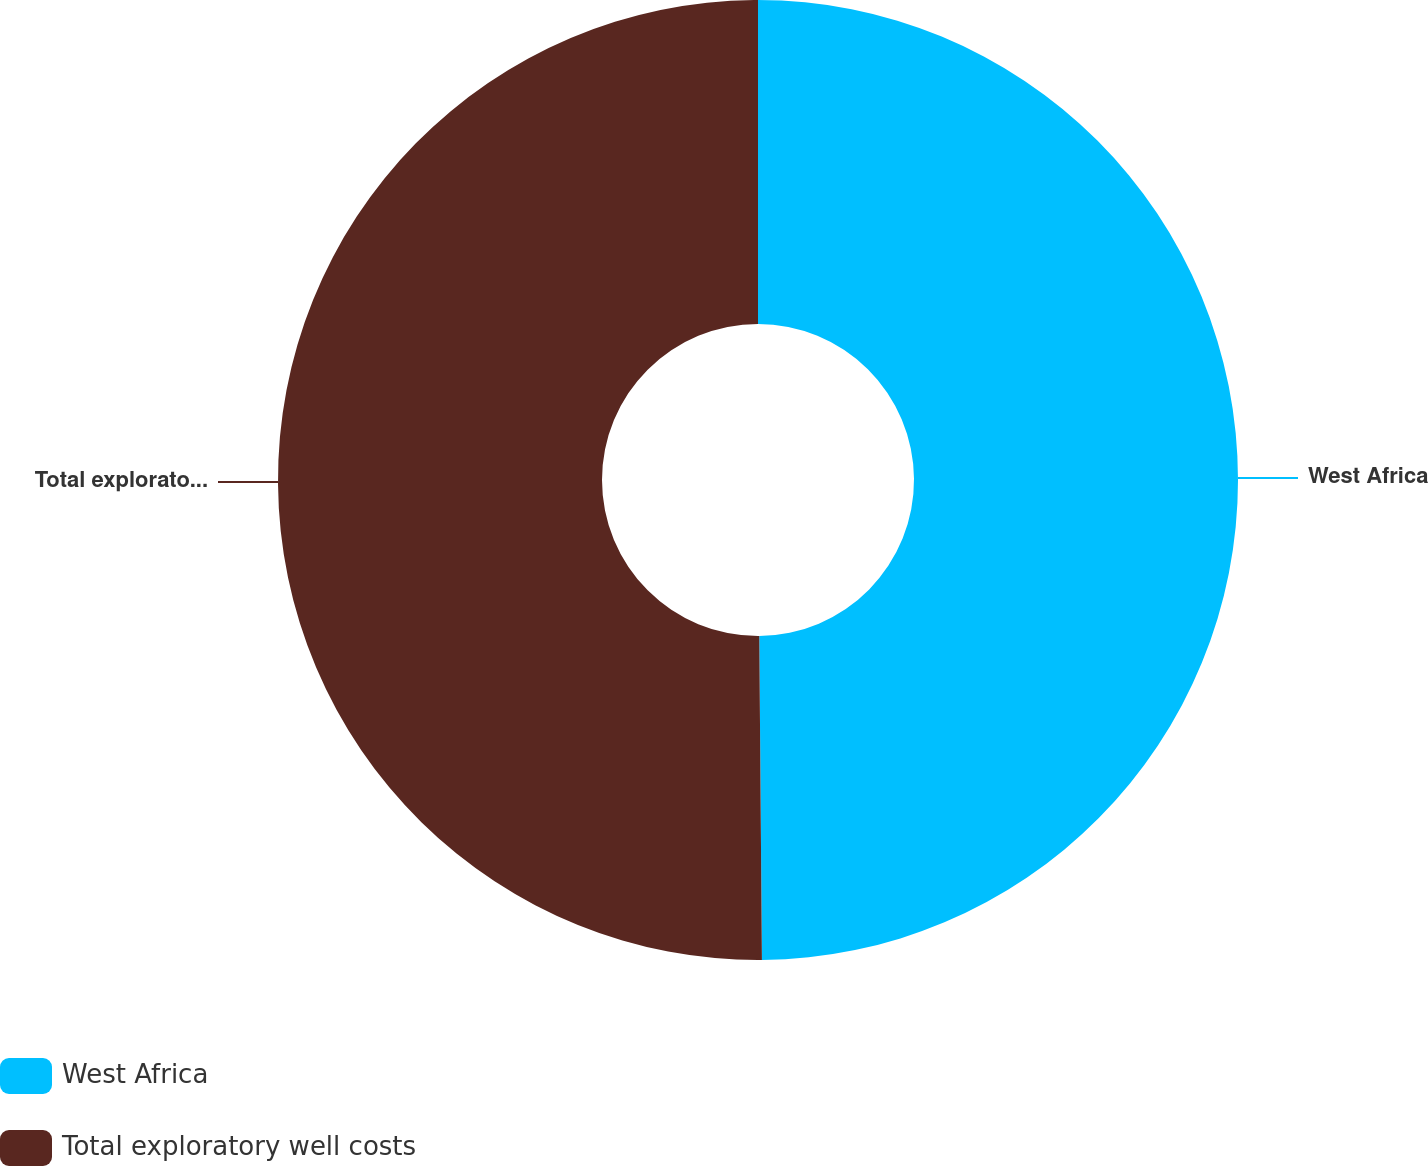<chart> <loc_0><loc_0><loc_500><loc_500><pie_chart><fcel>West Africa<fcel>Total exploratory well costs<nl><fcel>49.87%<fcel>50.13%<nl></chart> 